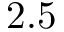<formula> <loc_0><loc_0><loc_500><loc_500>2 . 5</formula> 